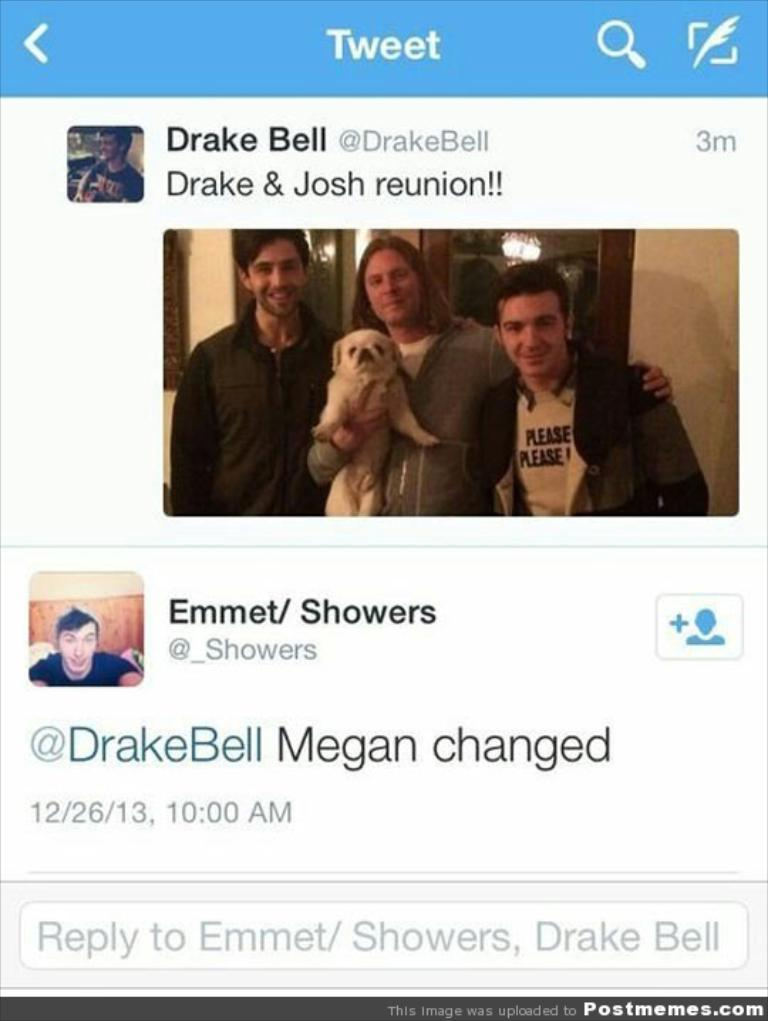What is the main object in the image? There is a screen in the image. What can be seen on the screen? There are images and text on the screen. What type of friction can be observed between the images and text on the screen? There is no friction observable between the images and text on the screen, as friction is a physical property related to the interaction between surfaces and not applicable to digital images and text. 